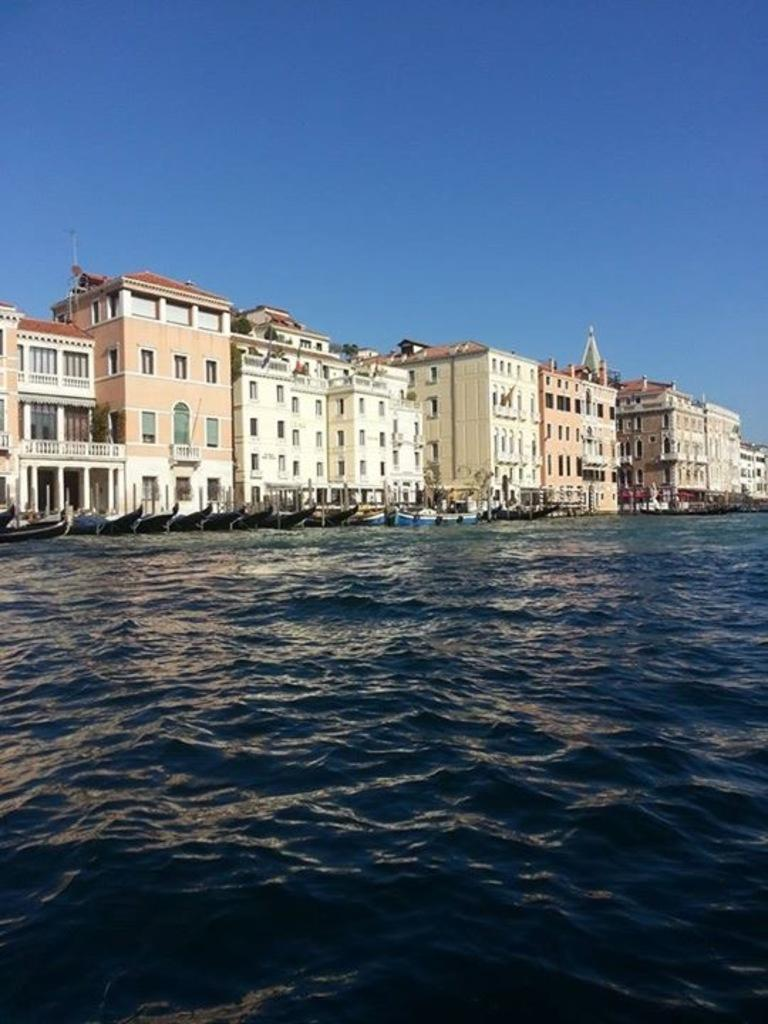What is the primary element in the image? The image contains water. What is floating on the water? There are boats in the water. What structures can be seen in the background? There are buildings visible in the image. Where are the fairies hiding in the image? There are no fairies present in the image. What type of bite can be seen on the boat in the image? There is no bite visible on the boat in the image. 